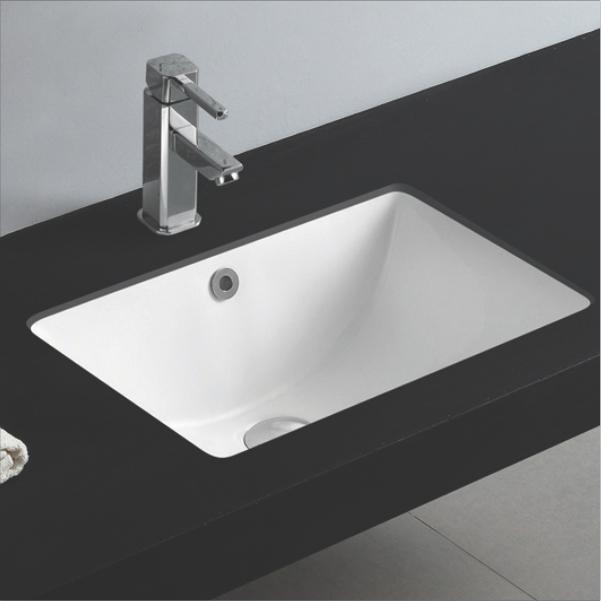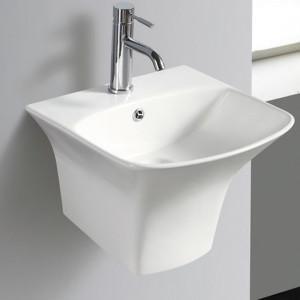The first image is the image on the left, the second image is the image on the right. For the images displayed, is the sentence "The image on the right has a plain white background." factually correct? Answer yes or no. No. 